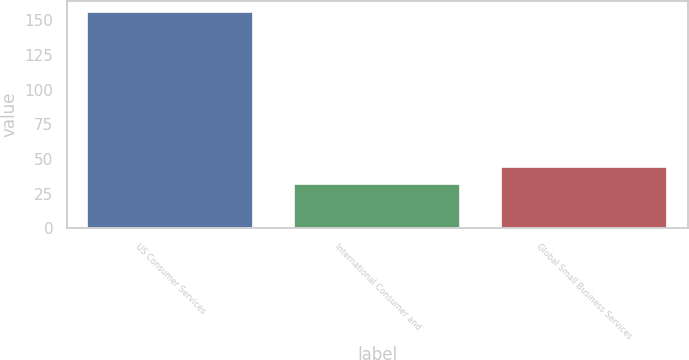Convert chart to OTSL. <chart><loc_0><loc_0><loc_500><loc_500><bar_chart><fcel>US Consumer Services<fcel>International Consumer and<fcel>Global Small Business Services<nl><fcel>156<fcel>32<fcel>44.4<nl></chart> 